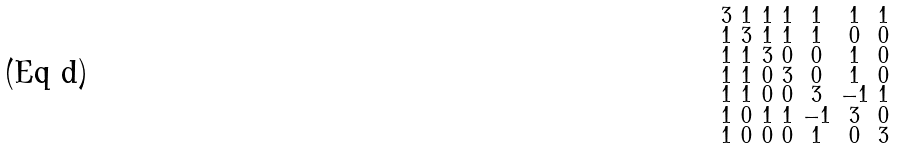<formula> <loc_0><loc_0><loc_500><loc_500>\begin{smallmatrix} 3 & 1 & 1 & 1 & 1 & 1 & 1 \\ 1 & 3 & 1 & 1 & 1 & 0 & 0 \\ 1 & 1 & 3 & 0 & 0 & 1 & 0 \\ 1 & 1 & 0 & 3 & 0 & 1 & 0 \\ 1 & 1 & 0 & 0 & 3 & - 1 & 1 \\ 1 & 0 & 1 & 1 & - 1 & 3 & 0 \\ 1 & 0 & 0 & 0 & 1 & 0 & 3 \end{smallmatrix}</formula> 